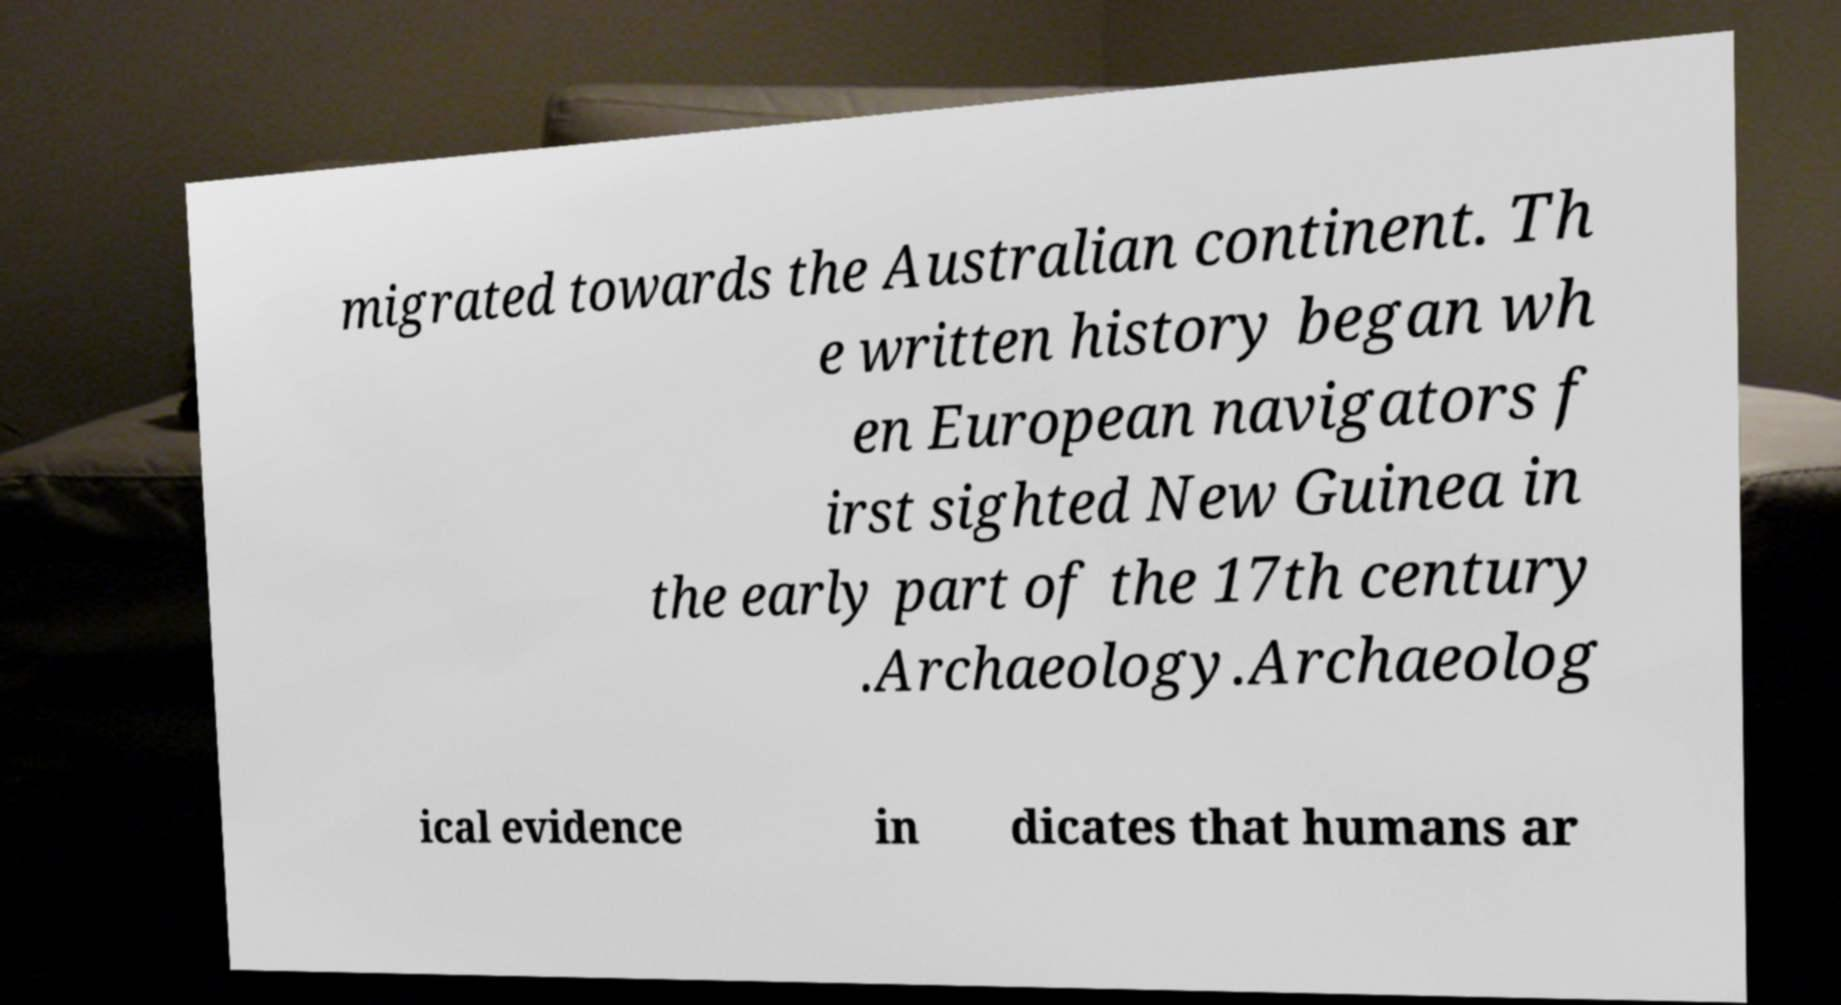Could you assist in decoding the text presented in this image and type it out clearly? migrated towards the Australian continent. Th e written history began wh en European navigators f irst sighted New Guinea in the early part of the 17th century .Archaeology.Archaeolog ical evidence in dicates that humans ar 